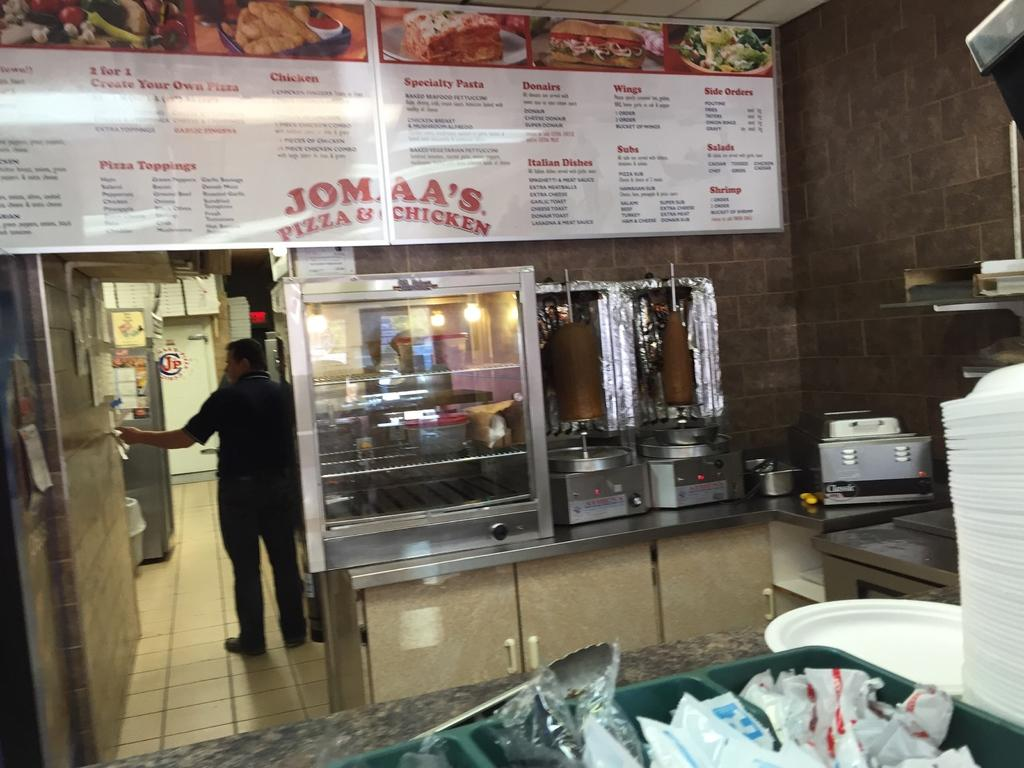<image>
Offer a succinct explanation of the picture presented. A restaurant with their menu on a sign and it says Jomaa's Pizza and Chicken on it. 